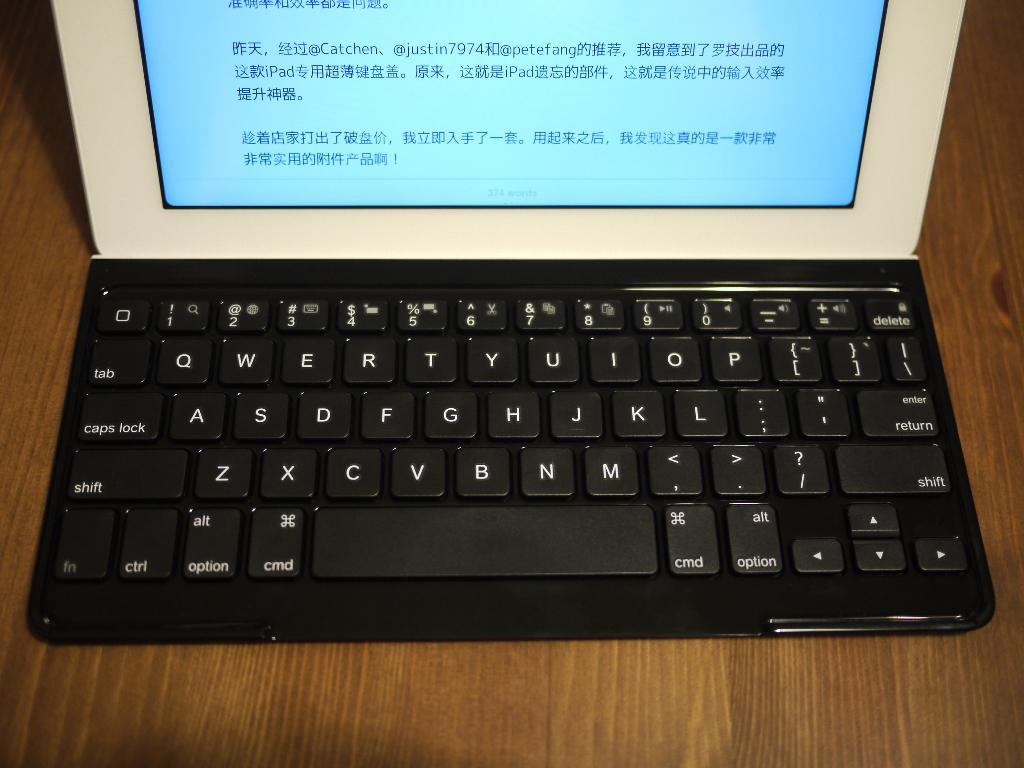<image>
Provide a brief description of the given image. Small laptop that have chinese words written on it 